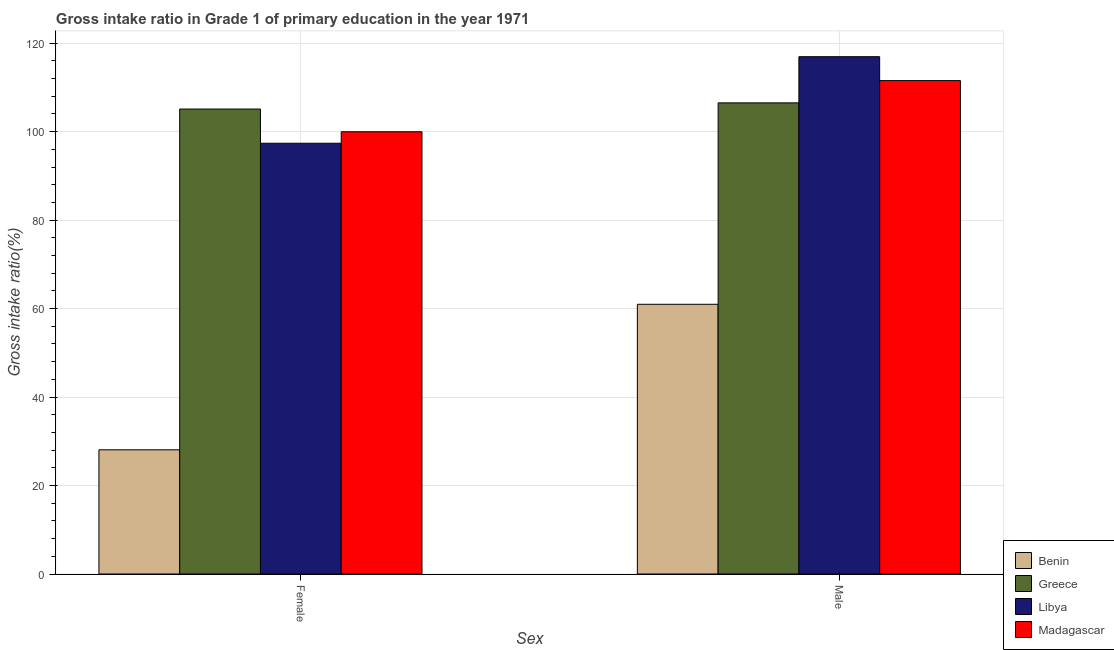How many different coloured bars are there?
Provide a short and direct response. 4. Are the number of bars per tick equal to the number of legend labels?
Make the answer very short. Yes. What is the gross intake ratio(male) in Greece?
Offer a terse response. 106.5. Across all countries, what is the maximum gross intake ratio(male)?
Your response must be concise. 116.94. Across all countries, what is the minimum gross intake ratio(male)?
Give a very brief answer. 60.97. In which country was the gross intake ratio(female) maximum?
Keep it short and to the point. Greece. In which country was the gross intake ratio(female) minimum?
Offer a terse response. Benin. What is the total gross intake ratio(male) in the graph?
Offer a very short reply. 395.95. What is the difference between the gross intake ratio(male) in Benin and that in Libya?
Make the answer very short. -55.97. What is the difference between the gross intake ratio(female) in Greece and the gross intake ratio(male) in Libya?
Ensure brevity in your answer.  -11.83. What is the average gross intake ratio(female) per country?
Provide a succinct answer. 82.63. What is the difference between the gross intake ratio(male) and gross intake ratio(female) in Benin?
Give a very brief answer. 32.9. In how many countries, is the gross intake ratio(male) greater than 108 %?
Offer a terse response. 2. What is the ratio of the gross intake ratio(female) in Greece to that in Benin?
Provide a succinct answer. 3.74. Is the gross intake ratio(female) in Madagascar less than that in Greece?
Give a very brief answer. Yes. In how many countries, is the gross intake ratio(female) greater than the average gross intake ratio(female) taken over all countries?
Give a very brief answer. 3. What does the 3rd bar from the left in Male represents?
Give a very brief answer. Libya. What does the 3rd bar from the right in Male represents?
Keep it short and to the point. Greece. How many bars are there?
Provide a short and direct response. 8. Are all the bars in the graph horizontal?
Provide a short and direct response. No. How many countries are there in the graph?
Ensure brevity in your answer.  4. What is the difference between two consecutive major ticks on the Y-axis?
Ensure brevity in your answer.  20. Does the graph contain any zero values?
Your answer should be compact. No. How many legend labels are there?
Your response must be concise. 4. What is the title of the graph?
Give a very brief answer. Gross intake ratio in Grade 1 of primary education in the year 1971. Does "Curacao" appear as one of the legend labels in the graph?
Keep it short and to the point. No. What is the label or title of the X-axis?
Make the answer very short. Sex. What is the label or title of the Y-axis?
Provide a succinct answer. Gross intake ratio(%). What is the Gross intake ratio(%) in Benin in Female?
Offer a very short reply. 28.07. What is the Gross intake ratio(%) in Greece in Female?
Make the answer very short. 105.11. What is the Gross intake ratio(%) in Libya in Female?
Provide a succinct answer. 97.38. What is the Gross intake ratio(%) of Madagascar in Female?
Give a very brief answer. 99.97. What is the Gross intake ratio(%) in Benin in Male?
Your answer should be compact. 60.97. What is the Gross intake ratio(%) in Greece in Male?
Your answer should be compact. 106.5. What is the Gross intake ratio(%) in Libya in Male?
Provide a succinct answer. 116.94. What is the Gross intake ratio(%) in Madagascar in Male?
Your answer should be very brief. 111.53. Across all Sex, what is the maximum Gross intake ratio(%) of Benin?
Provide a succinct answer. 60.97. Across all Sex, what is the maximum Gross intake ratio(%) in Greece?
Offer a very short reply. 106.5. Across all Sex, what is the maximum Gross intake ratio(%) in Libya?
Your answer should be very brief. 116.94. Across all Sex, what is the maximum Gross intake ratio(%) in Madagascar?
Your answer should be very brief. 111.53. Across all Sex, what is the minimum Gross intake ratio(%) of Benin?
Give a very brief answer. 28.07. Across all Sex, what is the minimum Gross intake ratio(%) of Greece?
Your response must be concise. 105.11. Across all Sex, what is the minimum Gross intake ratio(%) in Libya?
Make the answer very short. 97.38. Across all Sex, what is the minimum Gross intake ratio(%) in Madagascar?
Your response must be concise. 99.97. What is the total Gross intake ratio(%) in Benin in the graph?
Your answer should be compact. 89.04. What is the total Gross intake ratio(%) of Greece in the graph?
Your answer should be compact. 211.61. What is the total Gross intake ratio(%) in Libya in the graph?
Your answer should be very brief. 214.32. What is the total Gross intake ratio(%) in Madagascar in the graph?
Keep it short and to the point. 211.51. What is the difference between the Gross intake ratio(%) of Benin in Female and that in Male?
Provide a succinct answer. -32.9. What is the difference between the Gross intake ratio(%) of Greece in Female and that in Male?
Keep it short and to the point. -1.39. What is the difference between the Gross intake ratio(%) of Libya in Female and that in Male?
Provide a short and direct response. -19.57. What is the difference between the Gross intake ratio(%) in Madagascar in Female and that in Male?
Ensure brevity in your answer.  -11.56. What is the difference between the Gross intake ratio(%) in Benin in Female and the Gross intake ratio(%) in Greece in Male?
Provide a succinct answer. -78.43. What is the difference between the Gross intake ratio(%) in Benin in Female and the Gross intake ratio(%) in Libya in Male?
Offer a very short reply. -88.87. What is the difference between the Gross intake ratio(%) of Benin in Female and the Gross intake ratio(%) of Madagascar in Male?
Your answer should be compact. -83.46. What is the difference between the Gross intake ratio(%) in Greece in Female and the Gross intake ratio(%) in Libya in Male?
Offer a terse response. -11.83. What is the difference between the Gross intake ratio(%) of Greece in Female and the Gross intake ratio(%) of Madagascar in Male?
Provide a succinct answer. -6.42. What is the difference between the Gross intake ratio(%) of Libya in Female and the Gross intake ratio(%) of Madagascar in Male?
Give a very brief answer. -14.16. What is the average Gross intake ratio(%) in Benin per Sex?
Provide a short and direct response. 44.52. What is the average Gross intake ratio(%) of Greece per Sex?
Your answer should be compact. 105.81. What is the average Gross intake ratio(%) of Libya per Sex?
Make the answer very short. 107.16. What is the average Gross intake ratio(%) of Madagascar per Sex?
Provide a succinct answer. 105.75. What is the difference between the Gross intake ratio(%) in Benin and Gross intake ratio(%) in Greece in Female?
Keep it short and to the point. -77.04. What is the difference between the Gross intake ratio(%) of Benin and Gross intake ratio(%) of Libya in Female?
Offer a terse response. -69.3. What is the difference between the Gross intake ratio(%) in Benin and Gross intake ratio(%) in Madagascar in Female?
Keep it short and to the point. -71.9. What is the difference between the Gross intake ratio(%) of Greece and Gross intake ratio(%) of Libya in Female?
Your answer should be compact. 7.73. What is the difference between the Gross intake ratio(%) of Greece and Gross intake ratio(%) of Madagascar in Female?
Offer a terse response. 5.14. What is the difference between the Gross intake ratio(%) of Libya and Gross intake ratio(%) of Madagascar in Female?
Provide a succinct answer. -2.6. What is the difference between the Gross intake ratio(%) in Benin and Gross intake ratio(%) in Greece in Male?
Offer a terse response. -45.53. What is the difference between the Gross intake ratio(%) in Benin and Gross intake ratio(%) in Libya in Male?
Keep it short and to the point. -55.97. What is the difference between the Gross intake ratio(%) of Benin and Gross intake ratio(%) of Madagascar in Male?
Your answer should be compact. -50.56. What is the difference between the Gross intake ratio(%) of Greece and Gross intake ratio(%) of Libya in Male?
Make the answer very short. -10.44. What is the difference between the Gross intake ratio(%) in Greece and Gross intake ratio(%) in Madagascar in Male?
Offer a terse response. -5.03. What is the difference between the Gross intake ratio(%) of Libya and Gross intake ratio(%) of Madagascar in Male?
Your response must be concise. 5.41. What is the ratio of the Gross intake ratio(%) of Benin in Female to that in Male?
Provide a succinct answer. 0.46. What is the ratio of the Gross intake ratio(%) of Greece in Female to that in Male?
Your response must be concise. 0.99. What is the ratio of the Gross intake ratio(%) in Libya in Female to that in Male?
Your answer should be very brief. 0.83. What is the ratio of the Gross intake ratio(%) of Madagascar in Female to that in Male?
Provide a short and direct response. 0.9. What is the difference between the highest and the second highest Gross intake ratio(%) in Benin?
Offer a very short reply. 32.9. What is the difference between the highest and the second highest Gross intake ratio(%) of Greece?
Give a very brief answer. 1.39. What is the difference between the highest and the second highest Gross intake ratio(%) in Libya?
Ensure brevity in your answer.  19.57. What is the difference between the highest and the second highest Gross intake ratio(%) in Madagascar?
Your answer should be compact. 11.56. What is the difference between the highest and the lowest Gross intake ratio(%) in Benin?
Give a very brief answer. 32.9. What is the difference between the highest and the lowest Gross intake ratio(%) of Greece?
Keep it short and to the point. 1.39. What is the difference between the highest and the lowest Gross intake ratio(%) of Libya?
Provide a short and direct response. 19.57. What is the difference between the highest and the lowest Gross intake ratio(%) in Madagascar?
Ensure brevity in your answer.  11.56. 